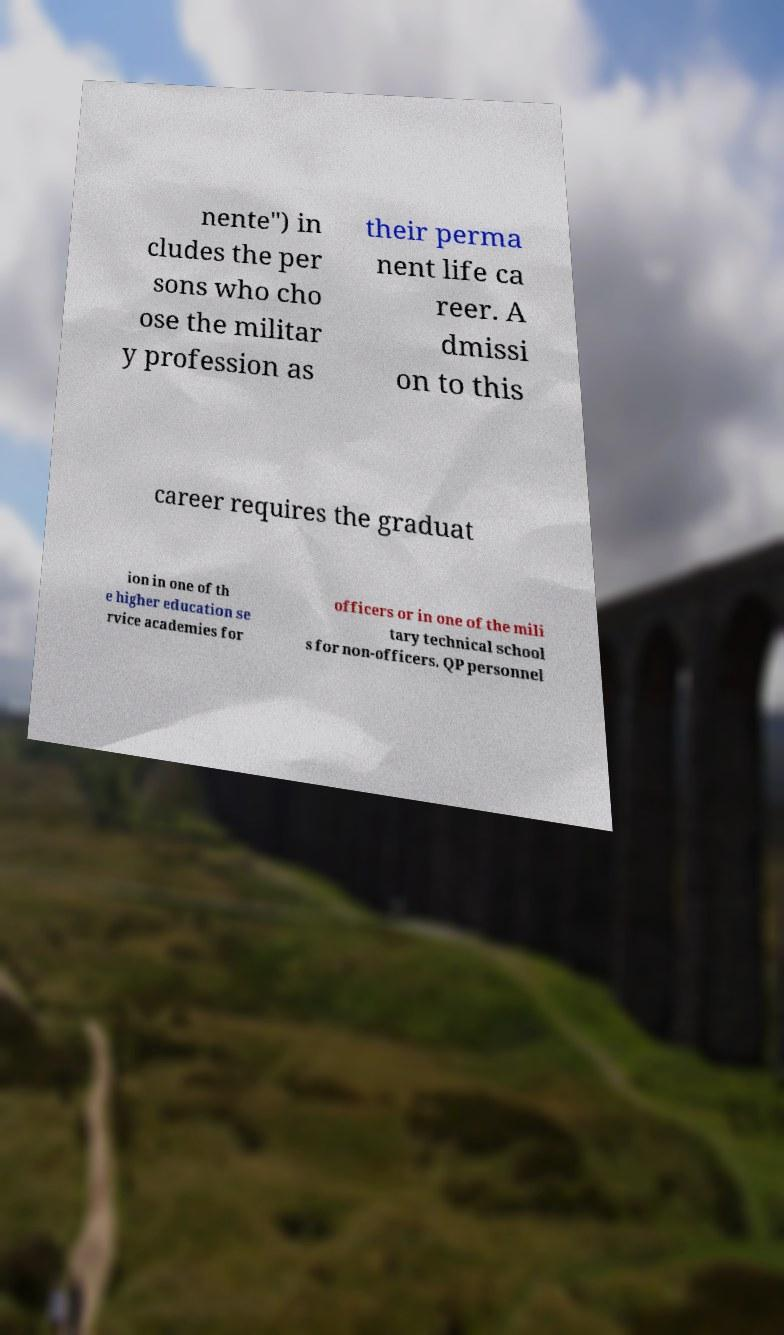Could you extract and type out the text from this image? nente") in cludes the per sons who cho ose the militar y profession as their perma nent life ca reer. A dmissi on to this career requires the graduat ion in one of th e higher education se rvice academies for officers or in one of the mili tary technical school s for non-officers. QP personnel 